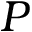<formula> <loc_0><loc_0><loc_500><loc_500>P</formula> 